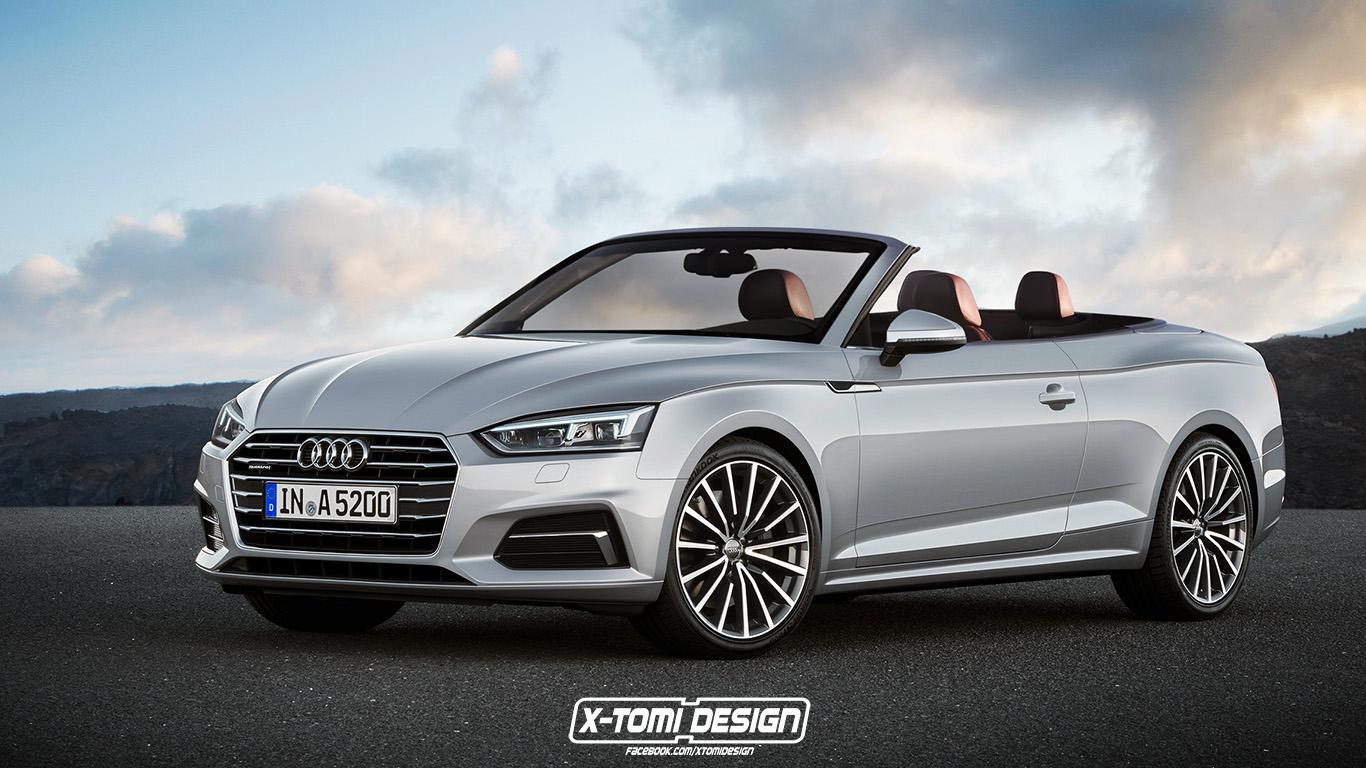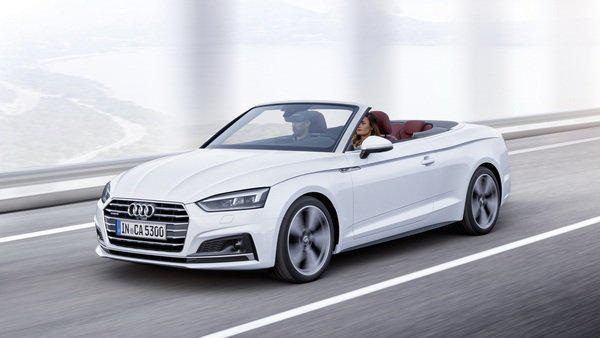The first image is the image on the left, the second image is the image on the right. Considering the images on both sides, is "There is at least one car facing towards the right side." valid? Answer yes or no. No. The first image is the image on the left, the second image is the image on the right. Given the left and right images, does the statement "The combined images include a topless white convertible with its rear to the camera moving leftward, and a topless convertible facing forward." hold true? Answer yes or no. No. 